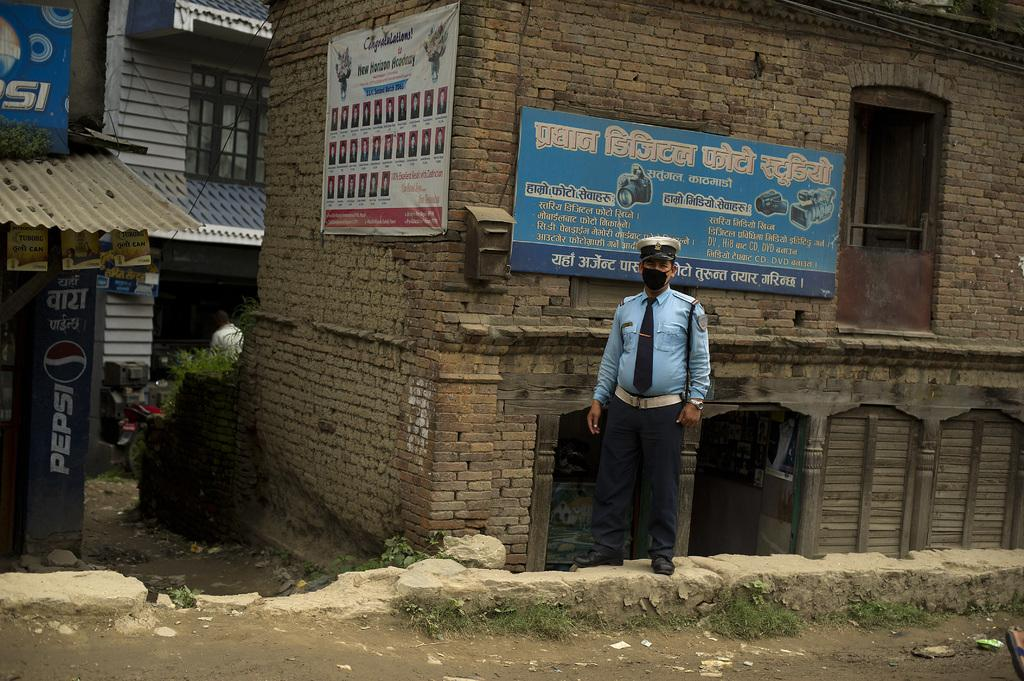What is the main subject of the image? There is a man standing in the image. What can be seen in the background of the image? There are houses in the background of the image. Are there any additional details on the houses? Yes, there is text written on the houses. How many legs does the word have in the image? There is no word with legs present in the image. 